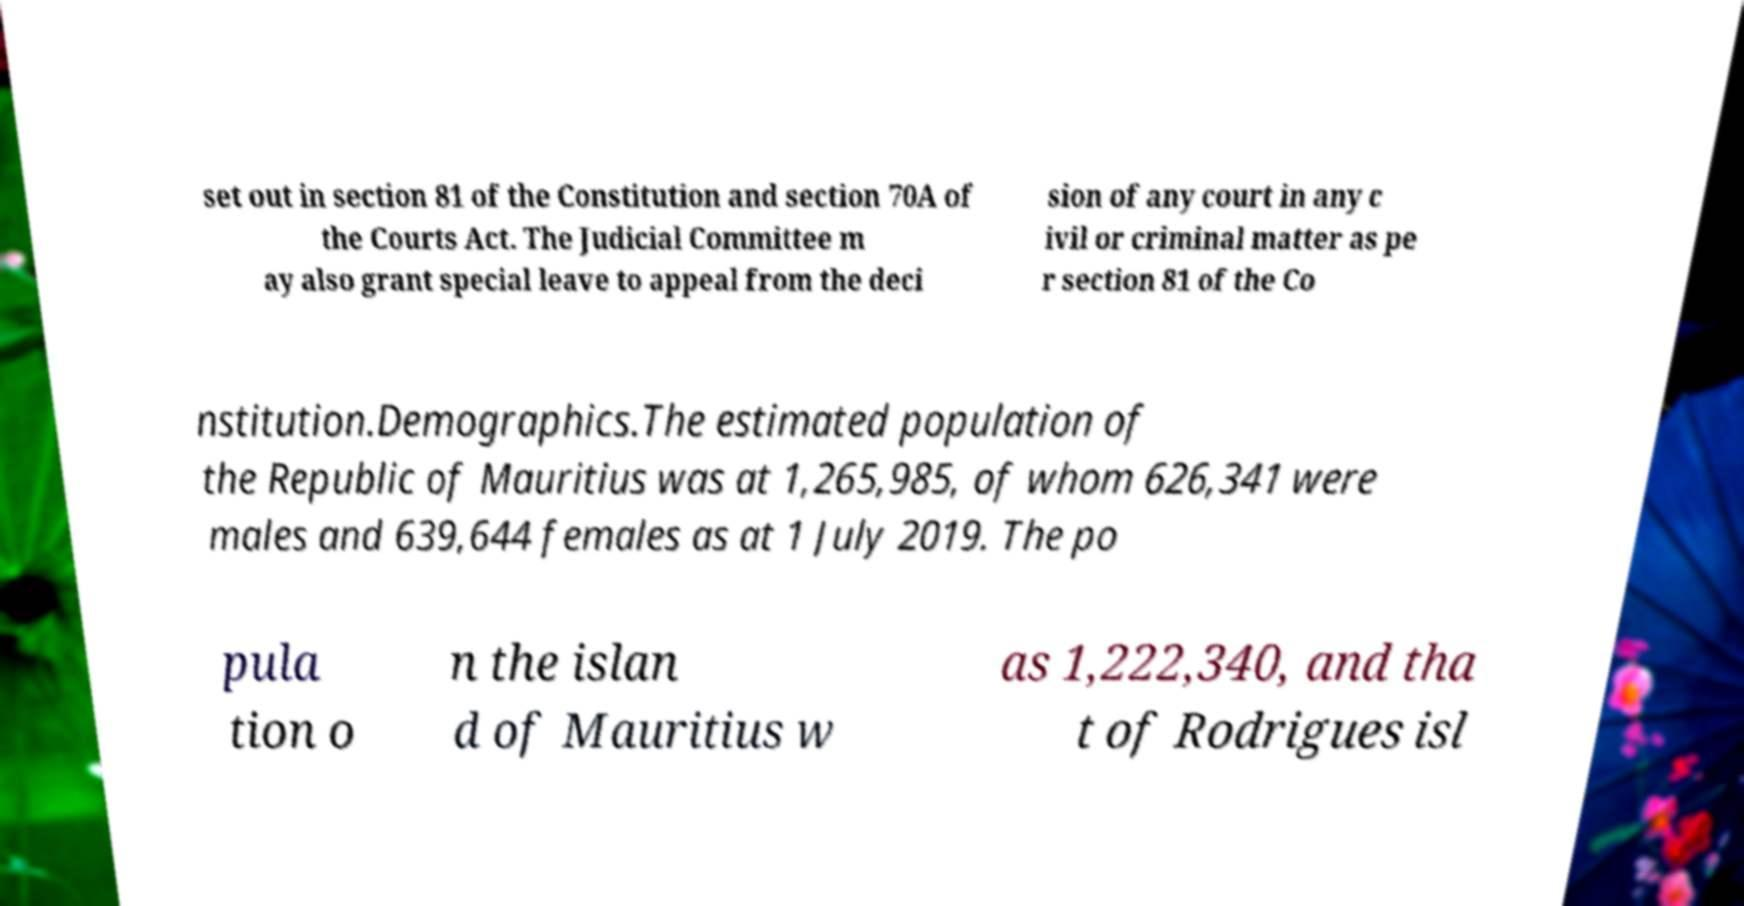Can you accurately transcribe the text from the provided image for me? set out in section 81 of the Constitution and section 70A of the Courts Act. The Judicial Committee m ay also grant special leave to appeal from the deci sion of any court in any c ivil or criminal matter as pe r section 81 of the Co nstitution.Demographics.The estimated population of the Republic of Mauritius was at 1,265,985, of whom 626,341 were males and 639,644 females as at 1 July 2019. The po pula tion o n the islan d of Mauritius w as 1,222,340, and tha t of Rodrigues isl 